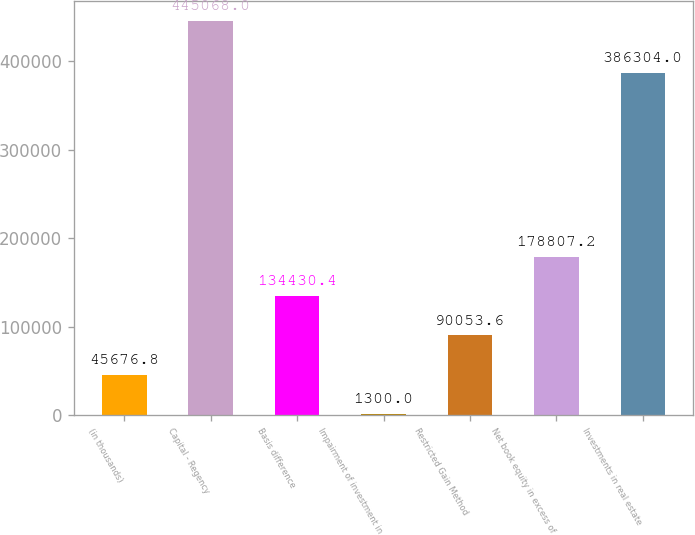Convert chart. <chart><loc_0><loc_0><loc_500><loc_500><bar_chart><fcel>(in thousands)<fcel>Capital - Regency<fcel>Basis difference<fcel>Impairment of investment in<fcel>Restricted Gain Method<fcel>Net book equity in excess of<fcel>Investments in real estate<nl><fcel>45676.8<fcel>445068<fcel>134430<fcel>1300<fcel>90053.6<fcel>178807<fcel>386304<nl></chart> 